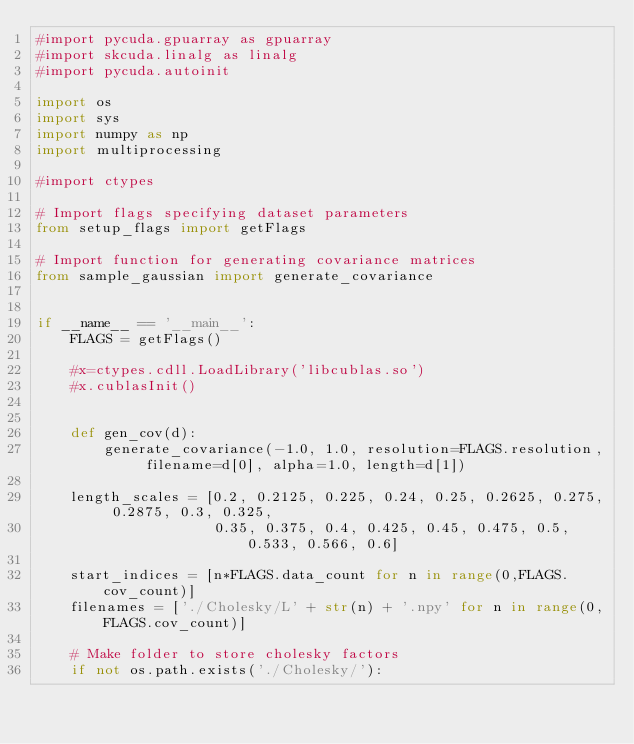<code> <loc_0><loc_0><loc_500><loc_500><_Python_>#import pycuda.gpuarray as gpuarray
#import skcuda.linalg as linalg
#import pycuda.autoinit

import os
import sys
import numpy as np
import multiprocessing

#import ctypes

# Import flags specifying dataset parameters
from setup_flags import getFlags

# Import function for generating covariance matrices
from sample_gaussian import generate_covariance


if __name__ == '__main__':
    FLAGS = getFlags()

    #x=ctypes.cdll.LoadLibrary('libcublas.so')
    #x.cublasInit()


    def gen_cov(d):
        generate_covariance(-1.0, 1.0, resolution=FLAGS.resolution, filename=d[0], alpha=1.0, length=d[1])

    length_scales = [0.2, 0.2125, 0.225, 0.24, 0.25, 0.2625, 0.275, 0.2875, 0.3, 0.325,
                     0.35, 0.375, 0.4, 0.425, 0.45, 0.475, 0.5, 0.533, 0.566, 0.6]

    start_indices = [n*FLAGS.data_count for n in range(0,FLAGS.cov_count)]
    filenames = ['./Cholesky/L' + str(n) + '.npy' for n in range(0,FLAGS.cov_count)]

    # Make folder to store cholesky factors
    if not os.path.exists('./Cholesky/'):</code> 